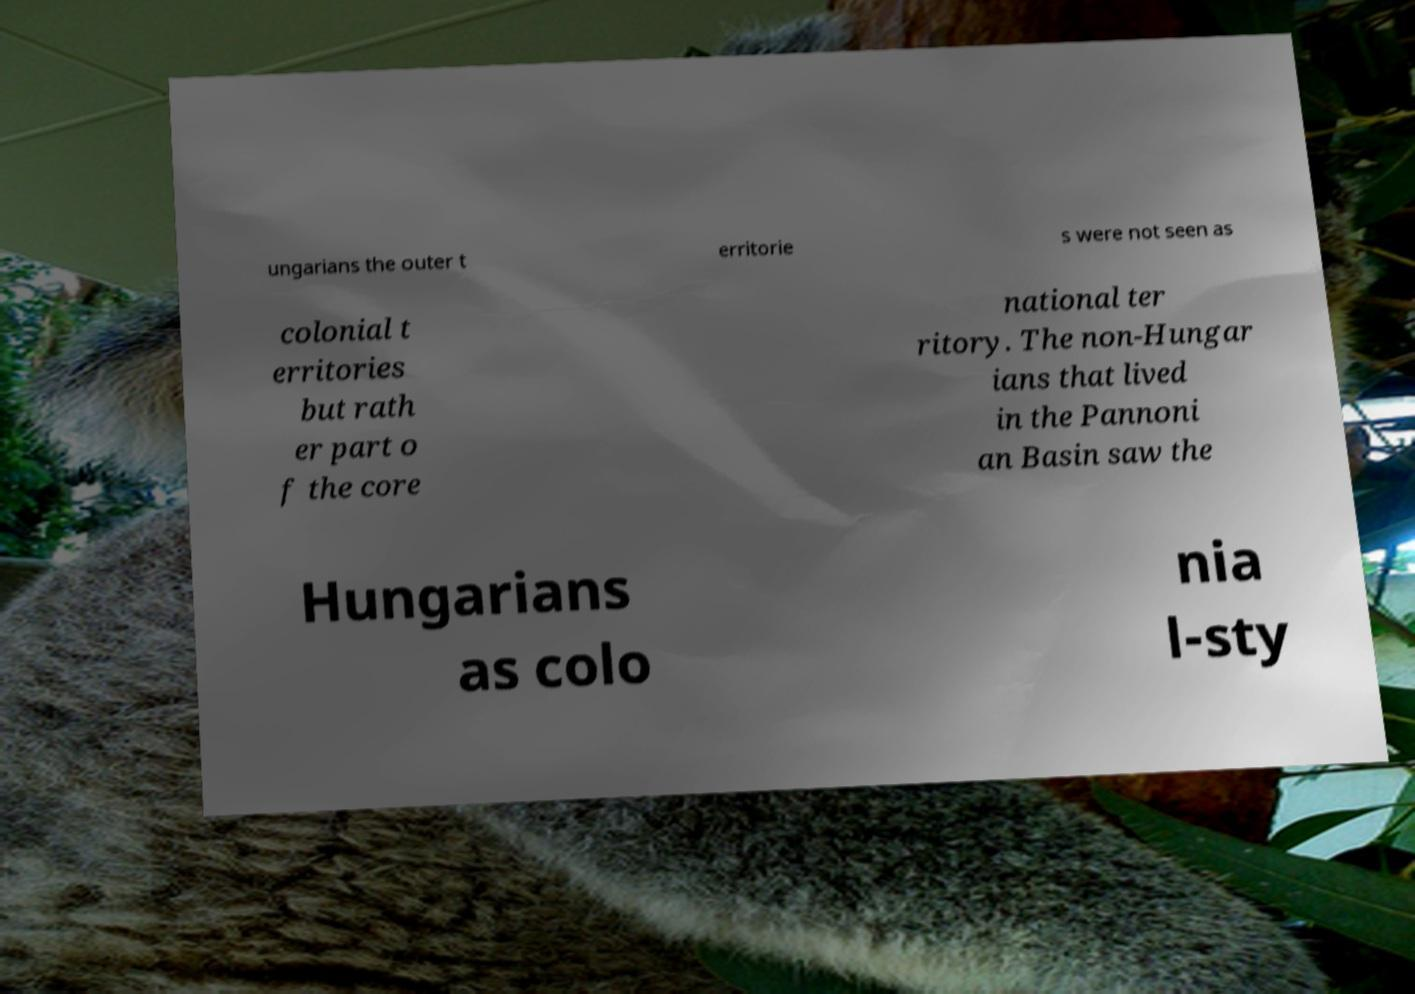Please identify and transcribe the text found in this image. ungarians the outer t erritorie s were not seen as colonial t erritories but rath er part o f the core national ter ritory. The non-Hungar ians that lived in the Pannoni an Basin saw the Hungarians as colo nia l-sty 